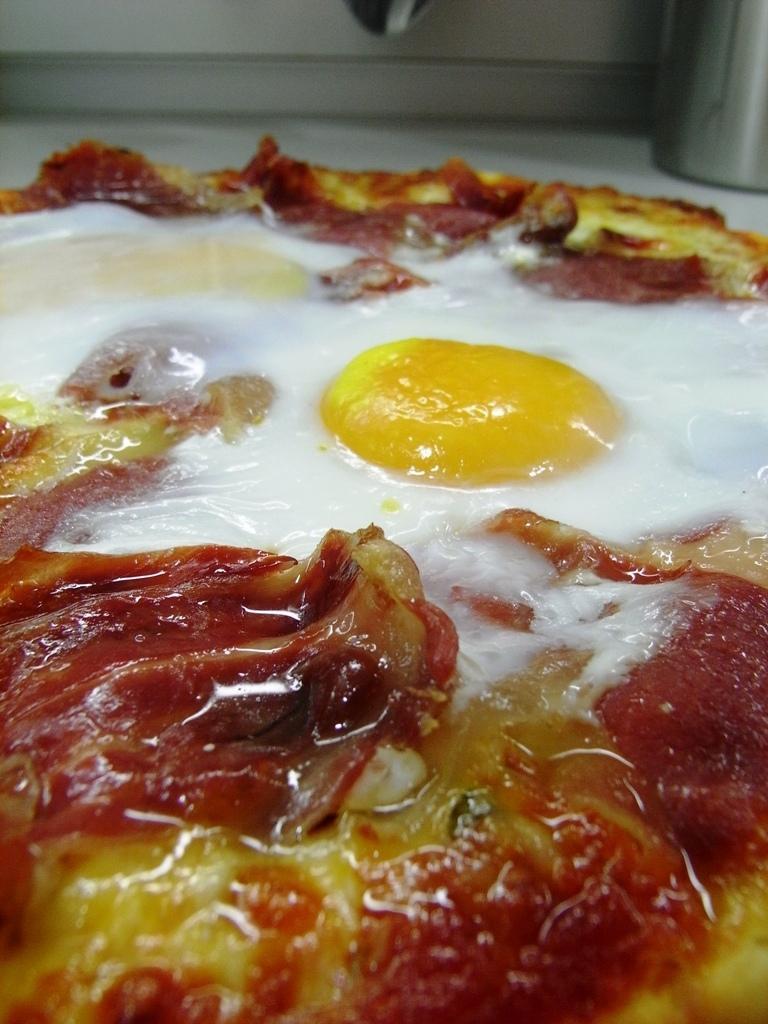Can you describe this image briefly? In the foreground of the picture there is a food item looking like a pizza. At the top there is a steel object. 